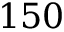Convert formula to latex. <formula><loc_0><loc_0><loc_500><loc_500>1 5 0</formula> 